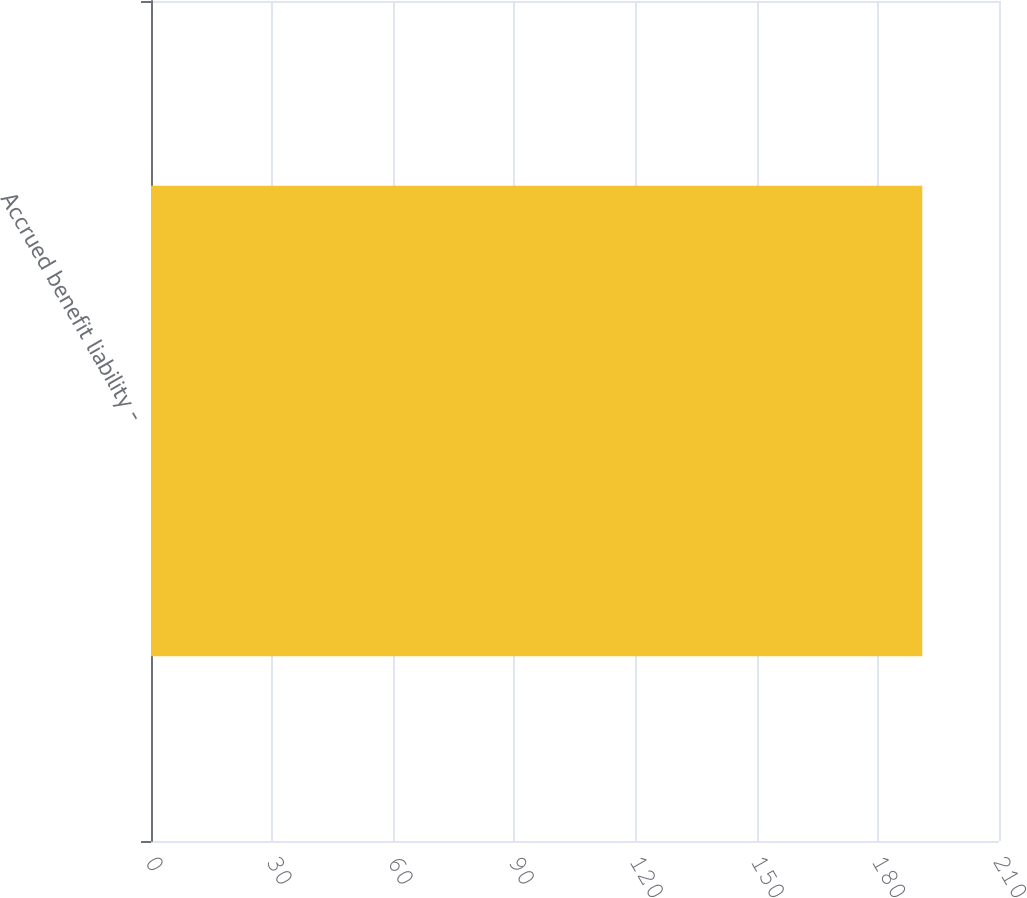<chart> <loc_0><loc_0><loc_500><loc_500><bar_chart><fcel>Accrued benefit liability -<nl><fcel>191<nl></chart> 